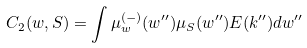<formula> <loc_0><loc_0><loc_500><loc_500>C _ { 2 } ( w , S ) = \int \mu _ { w } ^ { ( - ) } ( w ^ { \prime \prime } ) \mu _ { S } ( w ^ { \prime \prime } ) E ( { k ^ { \prime \prime } } ) d w ^ { \prime \prime }</formula> 